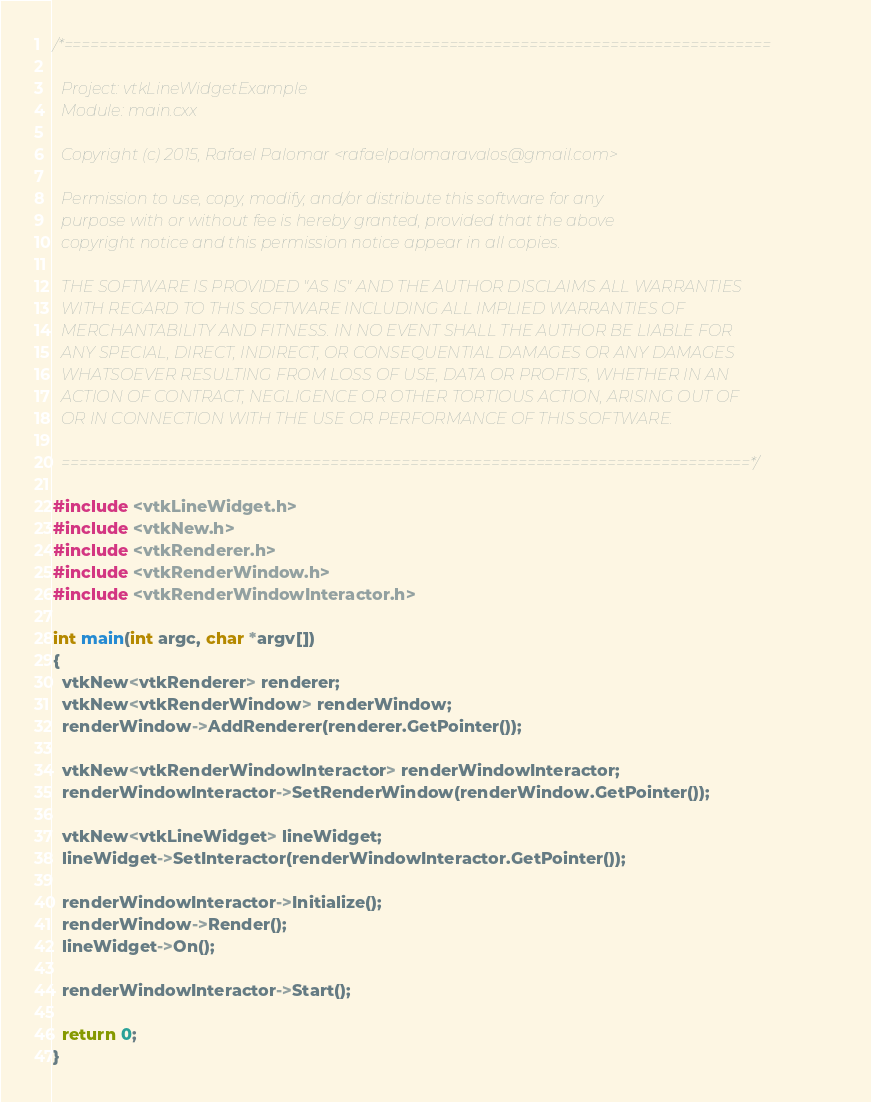<code> <loc_0><loc_0><loc_500><loc_500><_C++_>/*===============================================================================

  Project: vtkLineWidgetExample
  Module: main.cxx

  Copyright (c) 2015, Rafael Palomar <rafaelpalomaravalos@gmail.com>

  Permission to use, copy, modify, and/or distribute this software for any
  purpose with or without fee is hereby granted, provided that the above
  copyright notice and this permission notice appear in all copies.

  THE SOFTWARE IS PROVIDED "AS IS" AND THE AUTHOR DISCLAIMS ALL WARRANTIES
  WITH REGARD TO THIS SOFTWARE INCLUDING ALL IMPLIED WARRANTIES OF
  MERCHANTABILITY AND FITNESS. IN NO EVENT SHALL THE AUTHOR BE LIABLE FOR
  ANY SPECIAL, DIRECT, INDIRECT, OR CONSEQUENTIAL DAMAGES OR ANY DAMAGES
  WHATSOEVER RESULTING FROM LOSS OF USE, DATA OR PROFITS, WHETHER IN AN
  ACTION OF CONTRACT, NEGLIGENCE OR OTHER TORTIOUS ACTION, ARISING OUT OF
  OR IN CONNECTION WITH THE USE OR PERFORMANCE OF THIS SOFTWARE.

  =============================================================================*/

#include <vtkLineWidget.h>
#include <vtkNew.h>
#include <vtkRenderer.h>
#include <vtkRenderWindow.h>
#include <vtkRenderWindowInteractor.h>

int main(int argc, char *argv[])
{
  vtkNew<vtkRenderer> renderer;
  vtkNew<vtkRenderWindow> renderWindow;
  renderWindow->AddRenderer(renderer.GetPointer());

  vtkNew<vtkRenderWindowInteractor> renderWindowInteractor;
  renderWindowInteractor->SetRenderWindow(renderWindow.GetPointer());

  vtkNew<vtkLineWidget> lineWidget;
  lineWidget->SetInteractor(renderWindowInteractor.GetPointer());

  renderWindowInteractor->Initialize();
  renderWindow->Render();
  lineWidget->On();

  renderWindowInteractor->Start();

  return 0;
}
</code> 